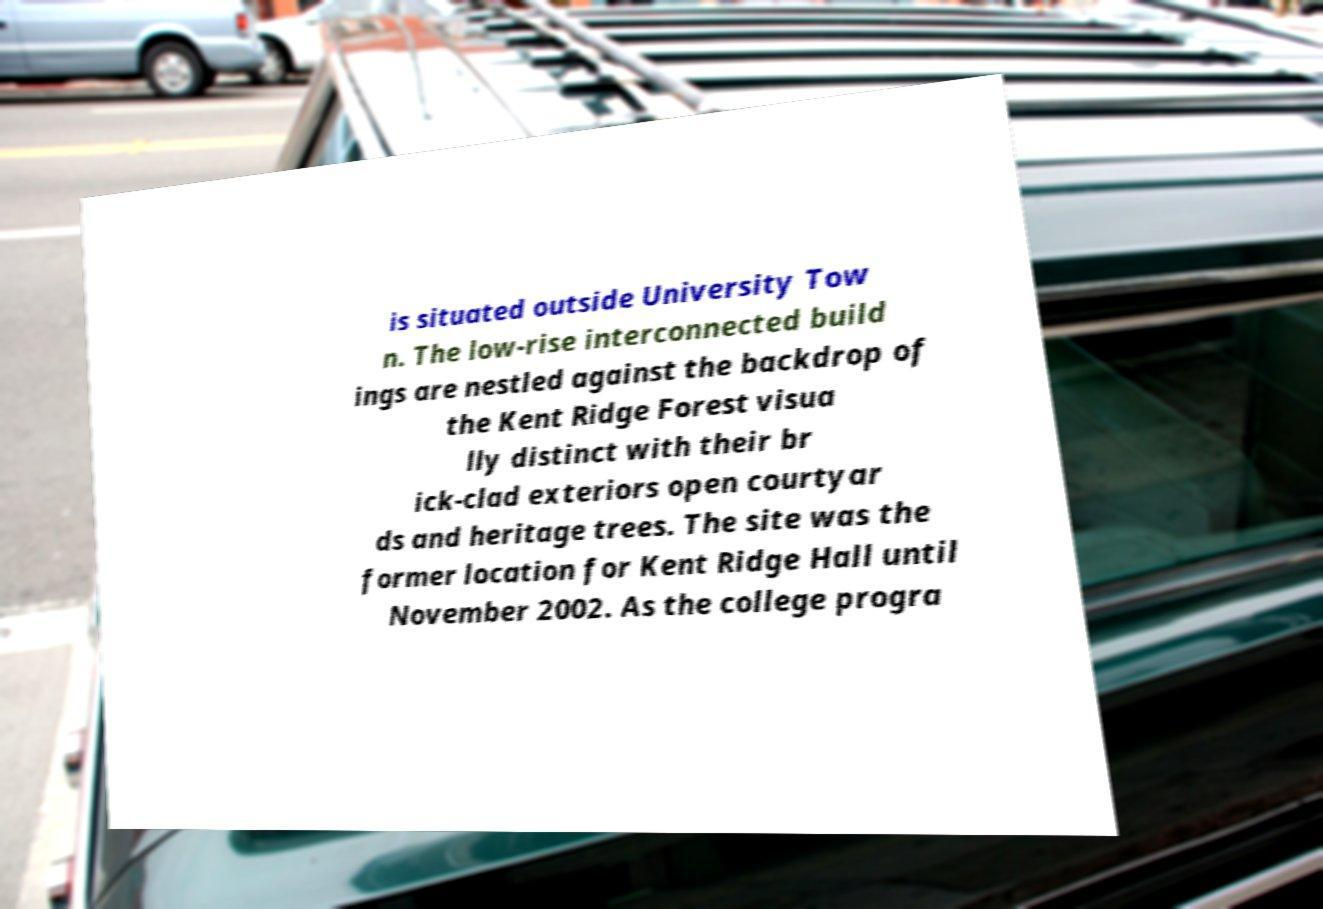For documentation purposes, I need the text within this image transcribed. Could you provide that? is situated outside University Tow n. The low-rise interconnected build ings are nestled against the backdrop of the Kent Ridge Forest visua lly distinct with their br ick-clad exteriors open courtyar ds and heritage trees. The site was the former location for Kent Ridge Hall until November 2002. As the college progra 